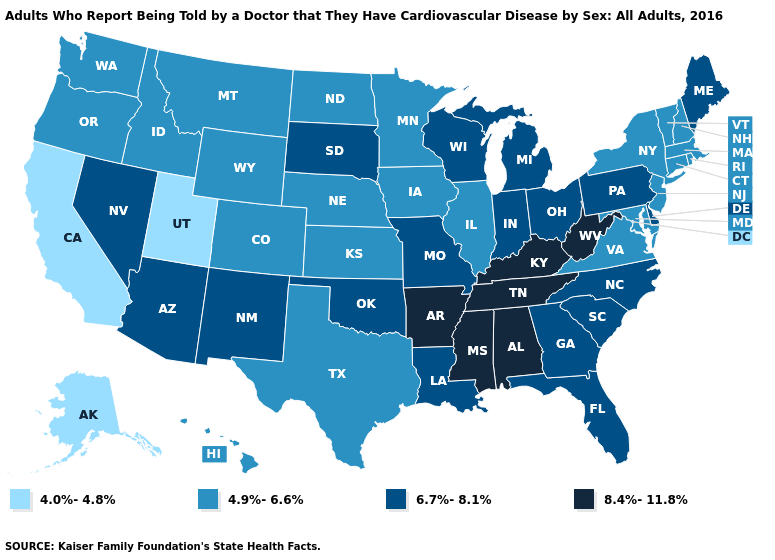What is the value of Michigan?
Keep it brief. 6.7%-8.1%. Name the states that have a value in the range 8.4%-11.8%?
Short answer required. Alabama, Arkansas, Kentucky, Mississippi, Tennessee, West Virginia. What is the value of Alabama?
Short answer required. 8.4%-11.8%. Name the states that have a value in the range 4.9%-6.6%?
Short answer required. Colorado, Connecticut, Hawaii, Idaho, Illinois, Iowa, Kansas, Maryland, Massachusetts, Minnesota, Montana, Nebraska, New Hampshire, New Jersey, New York, North Dakota, Oregon, Rhode Island, Texas, Vermont, Virginia, Washington, Wyoming. What is the lowest value in the West?
Give a very brief answer. 4.0%-4.8%. Name the states that have a value in the range 4.9%-6.6%?
Answer briefly. Colorado, Connecticut, Hawaii, Idaho, Illinois, Iowa, Kansas, Maryland, Massachusetts, Minnesota, Montana, Nebraska, New Hampshire, New Jersey, New York, North Dakota, Oregon, Rhode Island, Texas, Vermont, Virginia, Washington, Wyoming. Does Rhode Island have the highest value in the Northeast?
Write a very short answer. No. Does South Dakota have the lowest value in the MidWest?
Write a very short answer. No. What is the value of Texas?
Concise answer only. 4.9%-6.6%. What is the value of Tennessee?
Concise answer only. 8.4%-11.8%. What is the value of Wisconsin?
Quick response, please. 6.7%-8.1%. Which states have the lowest value in the West?
Give a very brief answer. Alaska, California, Utah. What is the highest value in the South ?
Give a very brief answer. 8.4%-11.8%. Which states have the lowest value in the USA?
Quick response, please. Alaska, California, Utah. Which states hav the highest value in the West?
Concise answer only. Arizona, Nevada, New Mexico. 